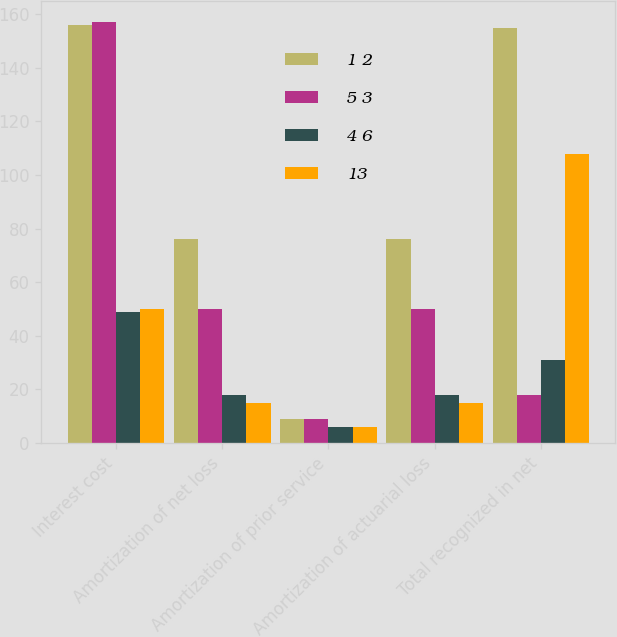<chart> <loc_0><loc_0><loc_500><loc_500><stacked_bar_chart><ecel><fcel>Interest cost<fcel>Amortization of net loss<fcel>Amortization of prior service<fcel>Amortization of actuarial loss<fcel>Total recognized in net<nl><fcel>1 2<fcel>156<fcel>76<fcel>9<fcel>76<fcel>155<nl><fcel>5 3<fcel>157<fcel>50<fcel>9<fcel>50<fcel>18<nl><fcel>4 6<fcel>49<fcel>18<fcel>6<fcel>18<fcel>31<nl><fcel>13<fcel>50<fcel>15<fcel>6<fcel>15<fcel>108<nl></chart> 